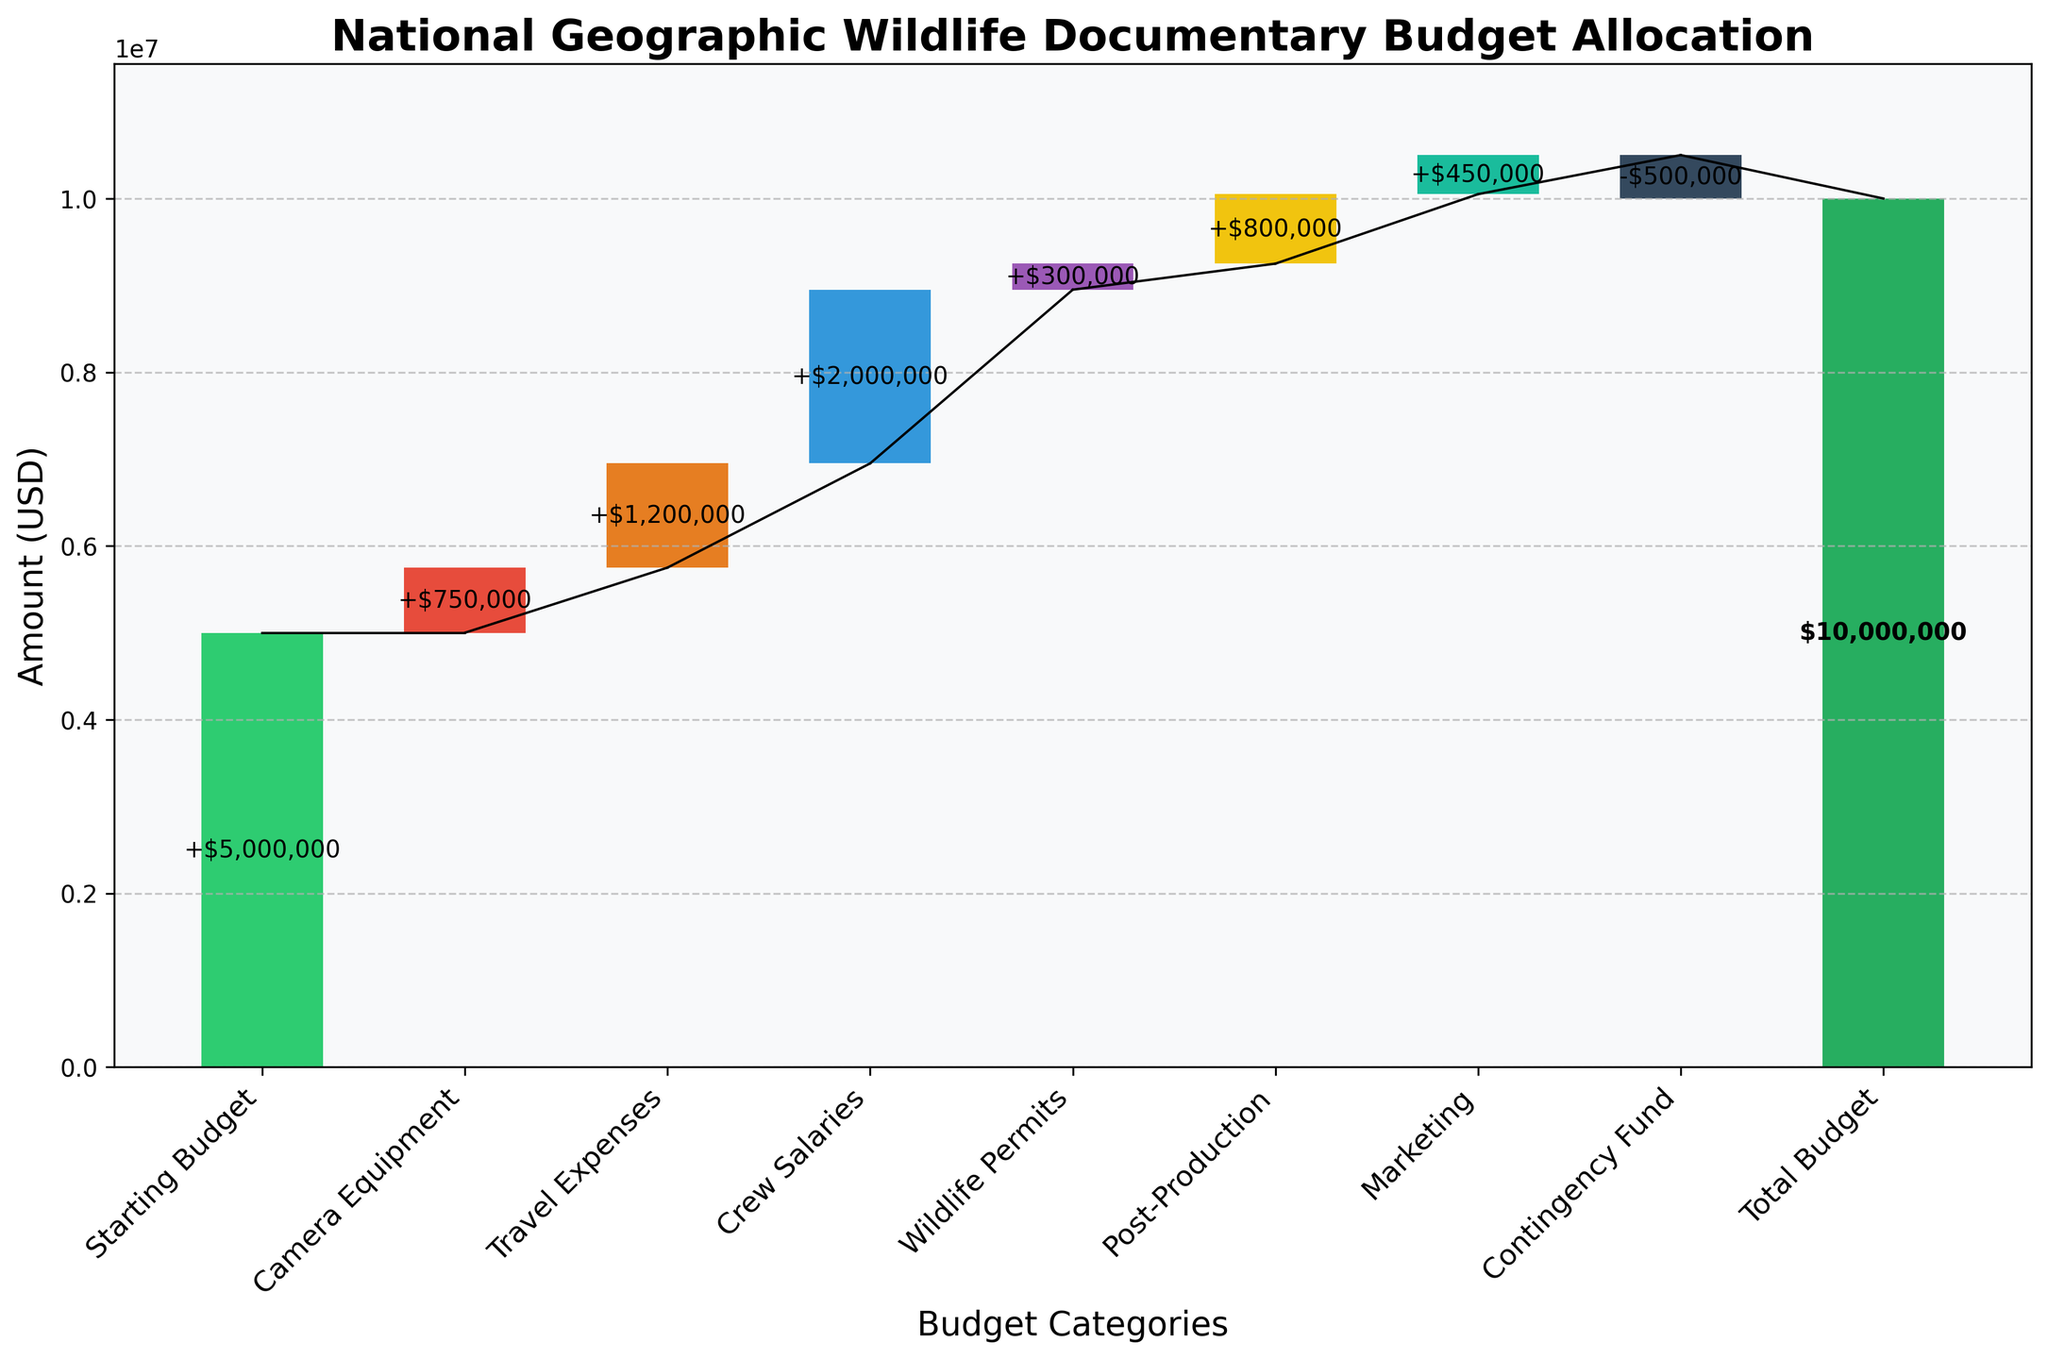What is the title of the chart? The title of the chart is prominently displayed at the top of the figure in a large and bold font. It gives an overview of what the chart is representing.
Answer: National Geographic Wildlife Documentary Budget Allocation How many budget categories are shown excluding the total? By counting the bars on the x-axis representing different budget categories, we can see the individual budget allocations before the total budget is shown.
Answer: 8 What color is used for the total budget bar? The color of the last bar, which represents the total budget, is distinct to make it easily recognizable from the other categories.
Answer: Green What does the Contingency Fund category represent in the chart? The Contingency Fund has a negative value, indicating a contingency or reserve fund set aside for unexpected expenses, which is represented as a deduction in the chart.
Answer: -$500,000 What is the total amount allocated for Travel Expenses and Crew Salaries? Summing the values of Travel Expenses and Crew Salaries (1200000 and 2000000 respectively) gives the combined amount allocated for these two categories.
Answer: $3,200,000 Which category has the highest expense, and what is its value? By comparing the heights of the bars representing each category, we can identify which one is the highest.
Answer: Crew Salaries, $2,000,000 What is the difference between the total amounts allocated to Camera Equipment and Marketing? Subtracting the value of Marketing from the value of Camera Equipment (750000 - 450000) gives the difference.
Answer: $300,000 How does the Post-Production expense compare to the Wildlife Permits expense? Comparing the heights of the bars corresponding to Post-Production and Wildlife Permits allows us to determine which is higher or lower.
Answer: Post-Production is higher by $500,000 Is the cumulative budget positive or negative after Crew Salaries are accounted for? By examining the cumulative sum plot and the bar representing Crew Salaries, we can see if the cumulative sum is above or below zero.
Answer: Positive What is the remaining budget after all categories except the total budget are accounted for? Calculating the cumulative sum of all individual categories except the last (total budget), we see how much of the initial budget is left.
Answer: $5,500,000 